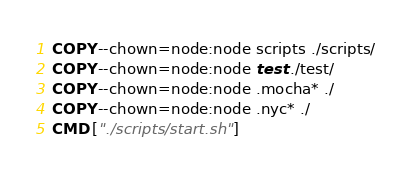Convert code to text. <code><loc_0><loc_0><loc_500><loc_500><_Dockerfile_>
COPY --chown=node:node scripts ./scripts/
COPY --chown=node:node test ./test/
COPY --chown=node:node .mocha* ./
COPY --chown=node:node .nyc* ./
CMD ["./scripts/start.sh"]
</code> 